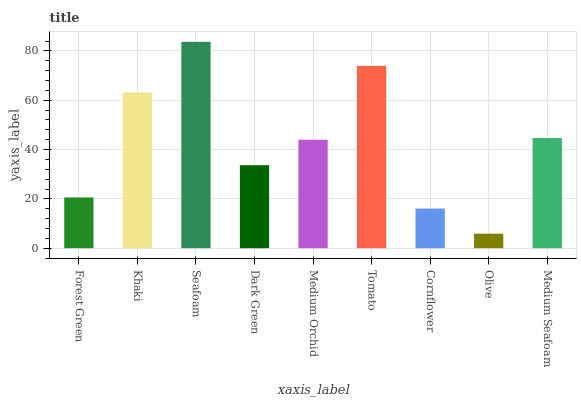Is Khaki the minimum?
Answer yes or no. No. Is Khaki the maximum?
Answer yes or no. No. Is Khaki greater than Forest Green?
Answer yes or no. Yes. Is Forest Green less than Khaki?
Answer yes or no. Yes. Is Forest Green greater than Khaki?
Answer yes or no. No. Is Khaki less than Forest Green?
Answer yes or no. No. Is Medium Orchid the high median?
Answer yes or no. Yes. Is Medium Orchid the low median?
Answer yes or no. Yes. Is Tomato the high median?
Answer yes or no. No. Is Forest Green the low median?
Answer yes or no. No. 